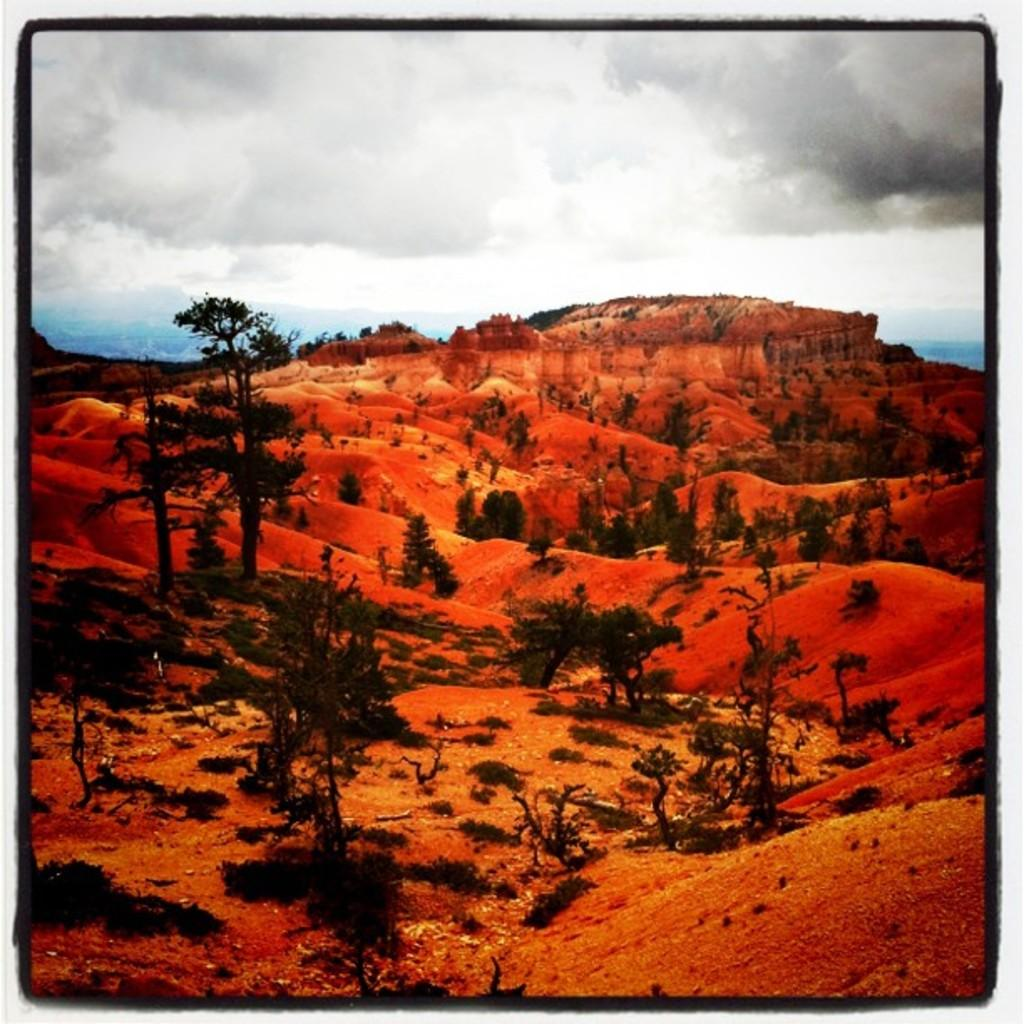What type of vegetation can be seen in the image? There are trees in the image. What type of terrain is visible in the image? There is sand in the image. What colors can be seen in the sky in the background of the image? The sky in the background of the image includes gray, white, and blue colors. What type of cup can be seen in the image? There is no cup present in the image. What is the mental state of the trees in the image? The mental state of the trees cannot be determined, as trees do not have mental states. 